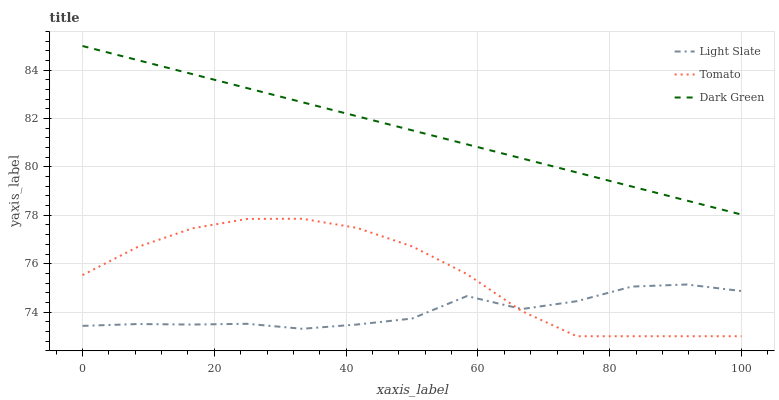Does Light Slate have the minimum area under the curve?
Answer yes or no. Yes. Does Dark Green have the maximum area under the curve?
Answer yes or no. Yes. Does Tomato have the minimum area under the curve?
Answer yes or no. No. Does Tomato have the maximum area under the curve?
Answer yes or no. No. Is Dark Green the smoothest?
Answer yes or no. Yes. Is Light Slate the roughest?
Answer yes or no. Yes. Is Tomato the smoothest?
Answer yes or no. No. Is Tomato the roughest?
Answer yes or no. No. Does Tomato have the lowest value?
Answer yes or no. Yes. Does Dark Green have the lowest value?
Answer yes or no. No. Does Dark Green have the highest value?
Answer yes or no. Yes. Does Tomato have the highest value?
Answer yes or no. No. Is Light Slate less than Dark Green?
Answer yes or no. Yes. Is Dark Green greater than Tomato?
Answer yes or no. Yes. Does Light Slate intersect Tomato?
Answer yes or no. Yes. Is Light Slate less than Tomato?
Answer yes or no. No. Is Light Slate greater than Tomato?
Answer yes or no. No. Does Light Slate intersect Dark Green?
Answer yes or no. No. 